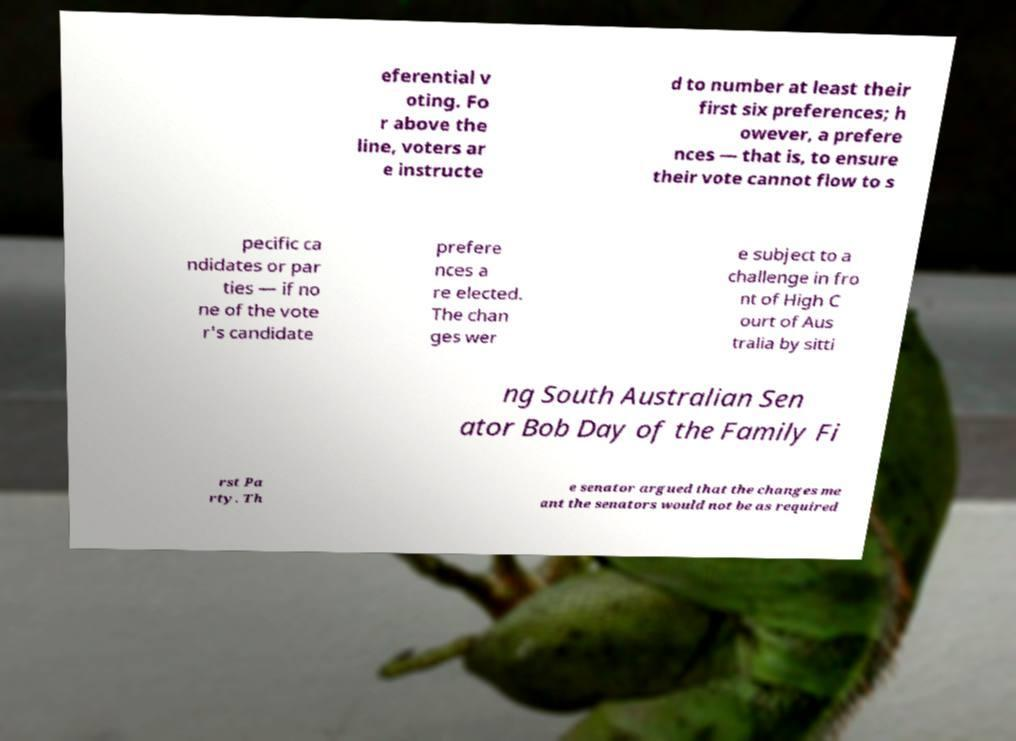Please identify and transcribe the text found in this image. eferential v oting. Fo r above the line, voters ar e instructe d to number at least their first six preferences; h owever, a prefere nces — that is, to ensure their vote cannot flow to s pecific ca ndidates or par ties — if no ne of the vote r's candidate prefere nces a re elected. The chan ges wer e subject to a challenge in fro nt of High C ourt of Aus tralia by sitti ng South Australian Sen ator Bob Day of the Family Fi rst Pa rty. Th e senator argued that the changes me ant the senators would not be as required 